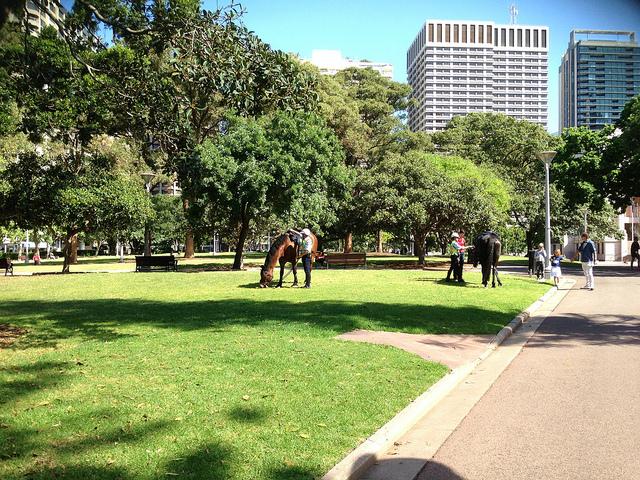Is this a park?
Write a very short answer. Yes. Where is the picnic table?
Answer briefly. Park. What are the shadows of?
Be succinct. Trees. When people sit on the bench is there any shade to keep them cool?
Answer briefly. Yes. Are there clouds here?
Be succinct. No. What is the grass for?
Concise answer only. Park. Is anyone sitting on the benches?
Quick response, please. No. 